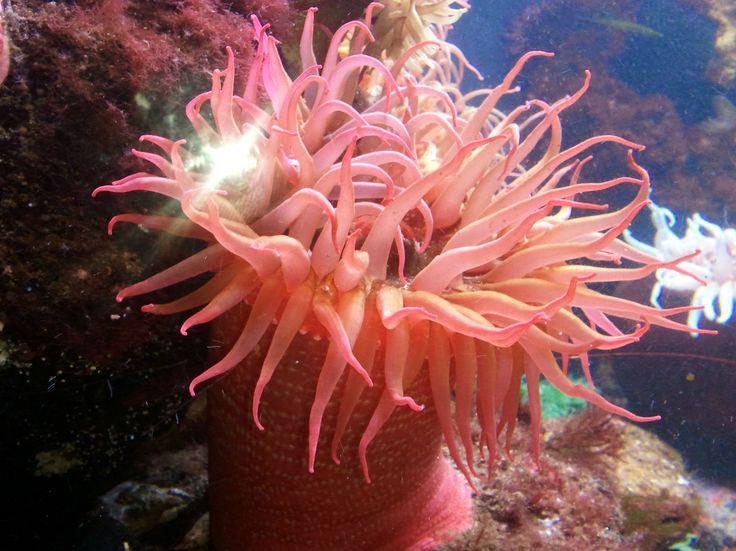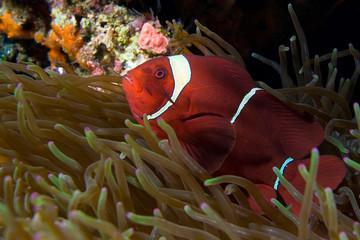The first image is the image on the left, the second image is the image on the right. Evaluate the accuracy of this statement regarding the images: "there is a clown fish in the image on the right". Is it true? Answer yes or no. Yes. The first image is the image on the left, the second image is the image on the right. Analyze the images presented: Is the assertion "There is a clownfish in at least one image." valid? Answer yes or no. Yes. 